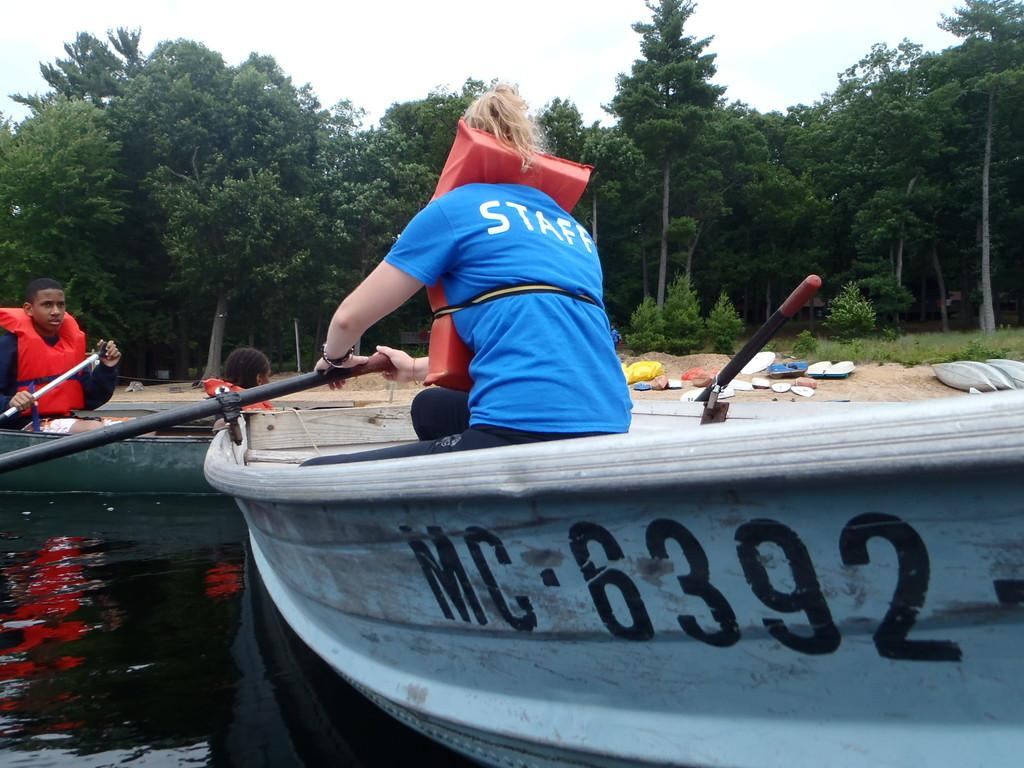What is the main subject of the image? The main subject of the image is water. What are the two people doing in the image? The two people are sitting on a boat in the water. What can be seen in the background of the image? There are trees in the background of the image. What is visible at the top of the image? The sky is visible at the top of the image. What type of pencil is being used by the person sitting on the boat in the image? There is no pencil visible in the image; the two people are sitting on a boat in the water. What type of property is being depicted in the image? The image does not depict any property; it features water, a boat, and two people sitting on the boat. 